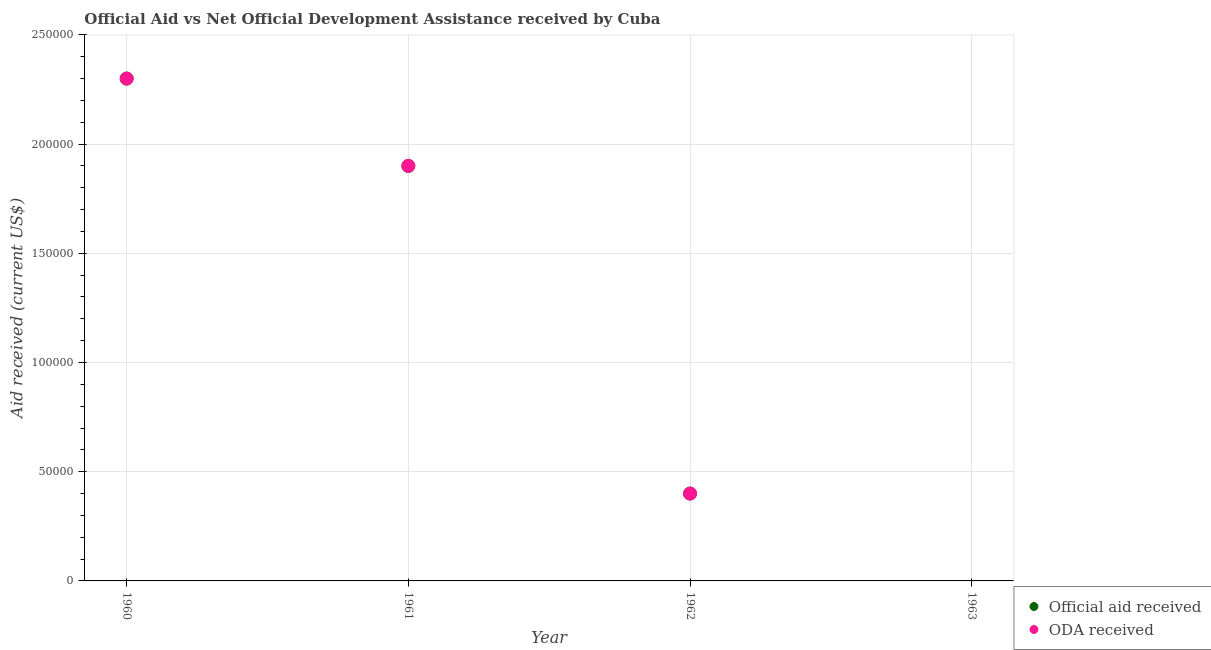How many different coloured dotlines are there?
Your response must be concise. 2. What is the oda received in 1962?
Your response must be concise. 4.00e+04. Across all years, what is the maximum official aid received?
Your answer should be compact. 2.30e+05. Across all years, what is the minimum official aid received?
Provide a succinct answer. 0. In which year was the official aid received maximum?
Provide a succinct answer. 1960. What is the total oda received in the graph?
Offer a terse response. 4.60e+05. What is the difference between the oda received in 1960 and that in 1961?
Ensure brevity in your answer.  4.00e+04. What is the difference between the oda received in 1963 and the official aid received in 1962?
Your response must be concise. -4.00e+04. What is the average oda received per year?
Provide a short and direct response. 1.15e+05. In how many years, is the oda received greater than 240000 US$?
Provide a succinct answer. 0. What is the ratio of the oda received in 1961 to that in 1962?
Provide a short and direct response. 4.75. Is the official aid received in 1961 less than that in 1962?
Your response must be concise. No. Is the difference between the oda received in 1960 and 1962 greater than the difference between the official aid received in 1960 and 1962?
Make the answer very short. No. What is the difference between the highest and the second highest official aid received?
Make the answer very short. 4.00e+04. What is the difference between the highest and the lowest official aid received?
Your answer should be very brief. 2.30e+05. Is the sum of the official aid received in 1960 and 1962 greater than the maximum oda received across all years?
Offer a very short reply. Yes. Does the oda received monotonically increase over the years?
Ensure brevity in your answer.  No. Is the oda received strictly less than the official aid received over the years?
Provide a succinct answer. No. Does the graph contain any zero values?
Offer a very short reply. Yes. How are the legend labels stacked?
Your answer should be very brief. Vertical. What is the title of the graph?
Keep it short and to the point. Official Aid vs Net Official Development Assistance received by Cuba . What is the label or title of the Y-axis?
Your response must be concise. Aid received (current US$). What is the Aid received (current US$) of Official aid received in 1961?
Offer a terse response. 1.90e+05. What is the Aid received (current US$) in ODA received in 1961?
Give a very brief answer. 1.90e+05. What is the Aid received (current US$) in Official aid received in 1962?
Your response must be concise. 4.00e+04. What is the Aid received (current US$) of ODA received in 1962?
Make the answer very short. 4.00e+04. What is the Aid received (current US$) of Official aid received in 1963?
Offer a terse response. 0. Across all years, what is the maximum Aid received (current US$) of Official aid received?
Offer a very short reply. 2.30e+05. Across all years, what is the minimum Aid received (current US$) of ODA received?
Ensure brevity in your answer.  0. What is the total Aid received (current US$) of Official aid received in the graph?
Your answer should be very brief. 4.60e+05. What is the total Aid received (current US$) of ODA received in the graph?
Provide a short and direct response. 4.60e+05. What is the difference between the Aid received (current US$) of ODA received in 1960 and that in 1961?
Your answer should be very brief. 4.00e+04. What is the difference between the Aid received (current US$) in ODA received in 1960 and that in 1962?
Your answer should be compact. 1.90e+05. What is the difference between the Aid received (current US$) of Official aid received in 1961 and that in 1962?
Offer a terse response. 1.50e+05. What is the difference between the Aid received (current US$) in ODA received in 1961 and that in 1962?
Give a very brief answer. 1.50e+05. What is the difference between the Aid received (current US$) of Official aid received in 1961 and the Aid received (current US$) of ODA received in 1962?
Ensure brevity in your answer.  1.50e+05. What is the average Aid received (current US$) of Official aid received per year?
Keep it short and to the point. 1.15e+05. What is the average Aid received (current US$) of ODA received per year?
Keep it short and to the point. 1.15e+05. In the year 1960, what is the difference between the Aid received (current US$) in Official aid received and Aid received (current US$) in ODA received?
Make the answer very short. 0. In the year 1961, what is the difference between the Aid received (current US$) of Official aid received and Aid received (current US$) of ODA received?
Your answer should be compact. 0. What is the ratio of the Aid received (current US$) of Official aid received in 1960 to that in 1961?
Your answer should be compact. 1.21. What is the ratio of the Aid received (current US$) in ODA received in 1960 to that in 1961?
Offer a very short reply. 1.21. What is the ratio of the Aid received (current US$) in Official aid received in 1960 to that in 1962?
Offer a very short reply. 5.75. What is the ratio of the Aid received (current US$) of ODA received in 1960 to that in 1962?
Give a very brief answer. 5.75. What is the ratio of the Aid received (current US$) of Official aid received in 1961 to that in 1962?
Your answer should be compact. 4.75. What is the ratio of the Aid received (current US$) in ODA received in 1961 to that in 1962?
Keep it short and to the point. 4.75. What is the difference between the highest and the second highest Aid received (current US$) of ODA received?
Give a very brief answer. 4.00e+04. 